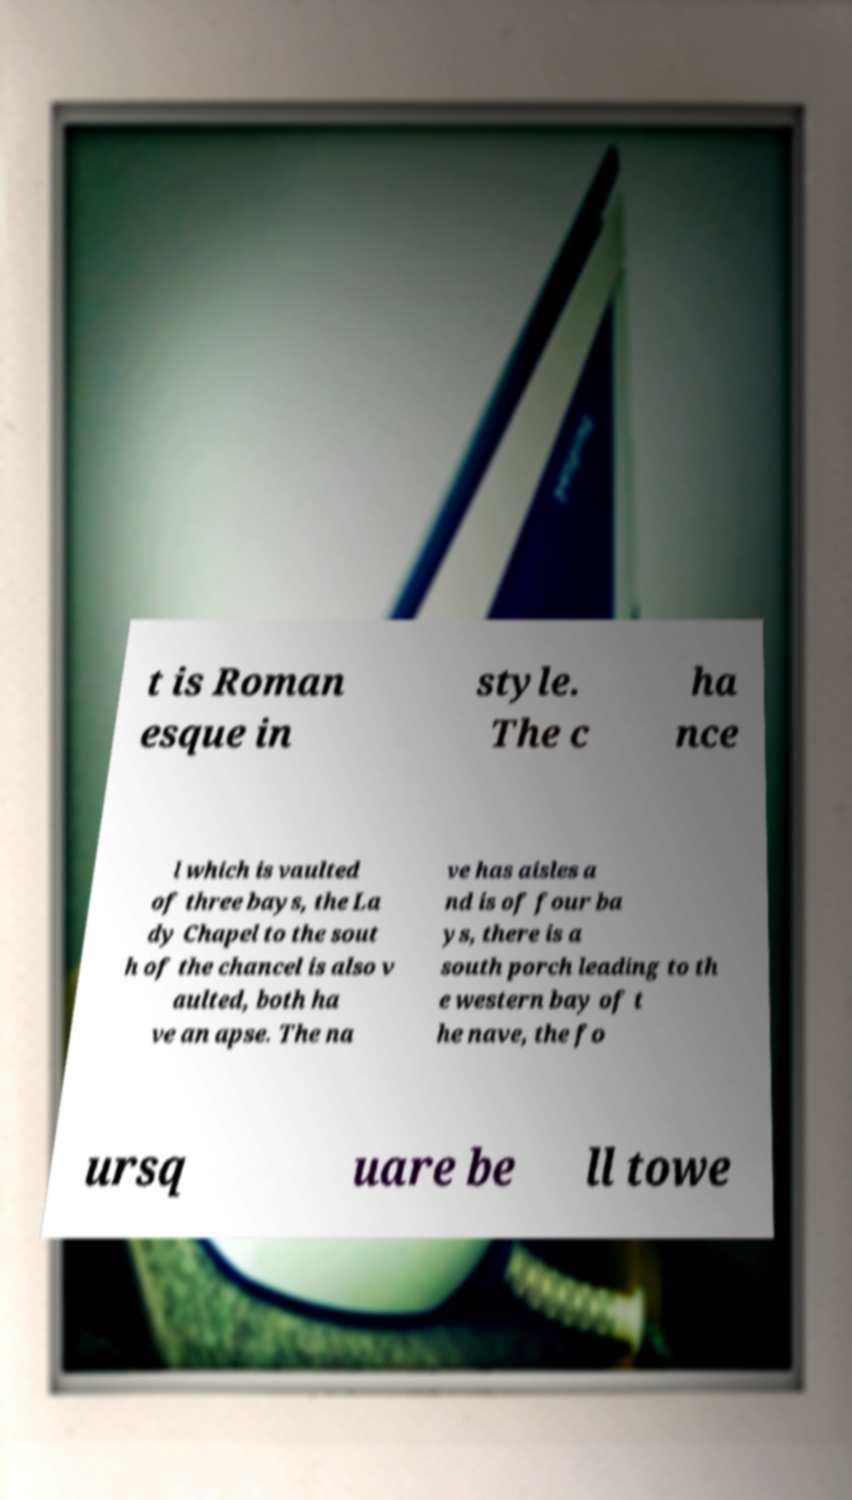Could you extract and type out the text from this image? t is Roman esque in style. The c ha nce l which is vaulted of three bays, the La dy Chapel to the sout h of the chancel is also v aulted, both ha ve an apse. The na ve has aisles a nd is of four ba ys, there is a south porch leading to th e western bay of t he nave, the fo ursq uare be ll towe 